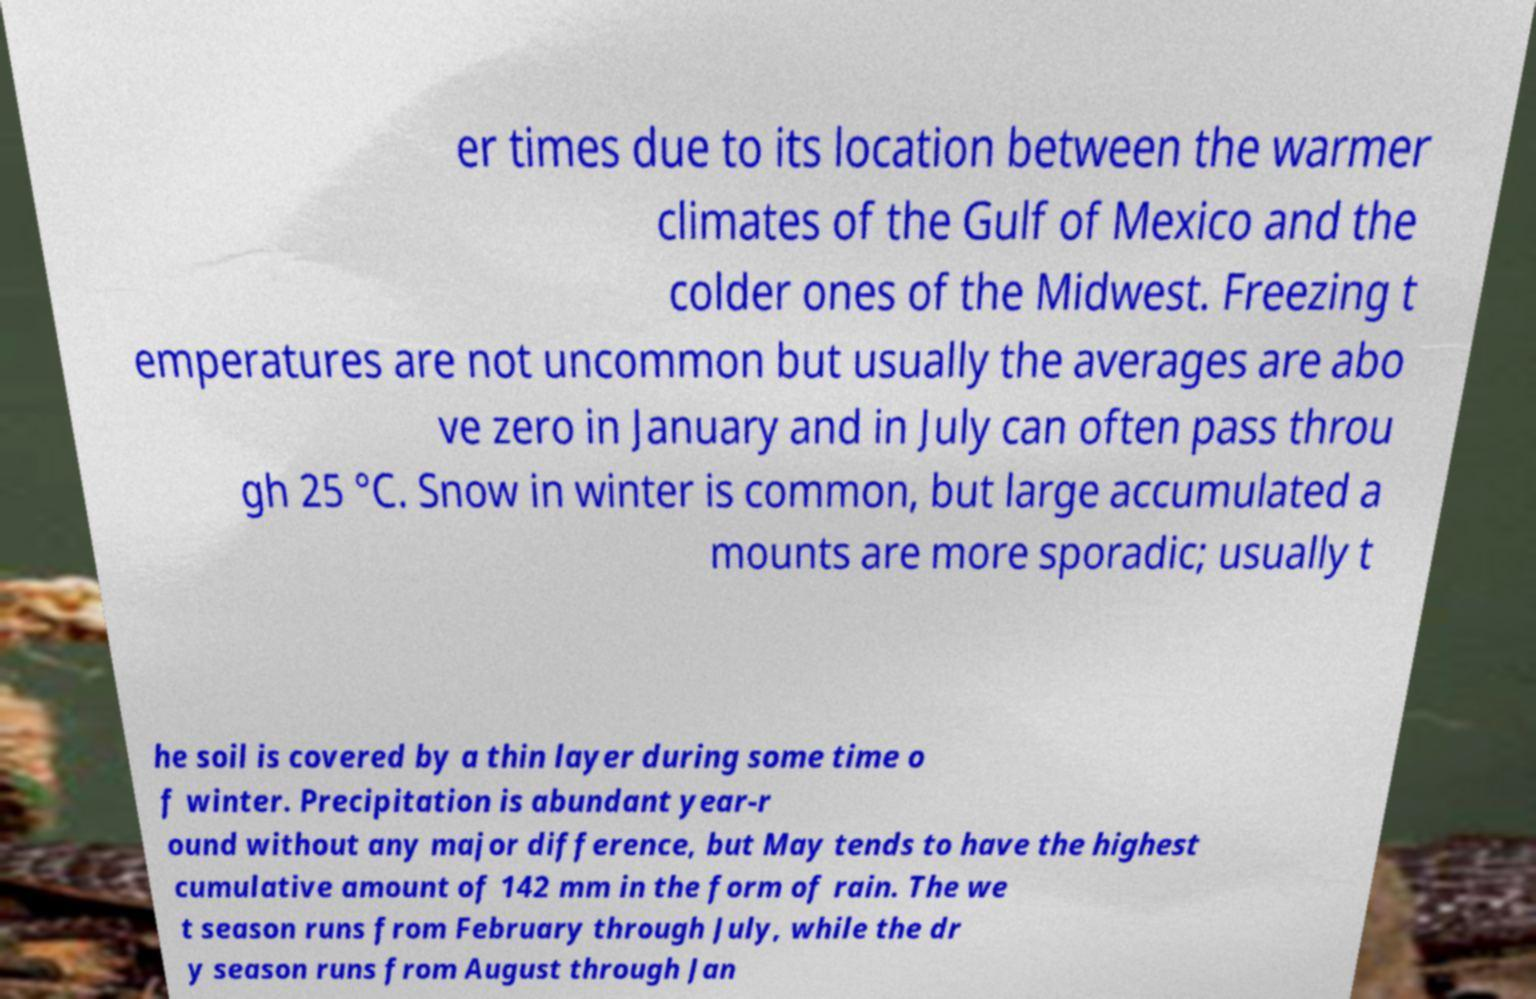Please identify and transcribe the text found in this image. er times due to its location between the warmer climates of the Gulf of Mexico and the colder ones of the Midwest. Freezing t emperatures are not uncommon but usually the averages are abo ve zero in January and in July can often pass throu gh 25 °C. Snow in winter is common, but large accumulated a mounts are more sporadic; usually t he soil is covered by a thin layer during some time o f winter. Precipitation is abundant year-r ound without any major difference, but May tends to have the highest cumulative amount of 142 mm in the form of rain. The we t season runs from February through July, while the dr y season runs from August through Jan 